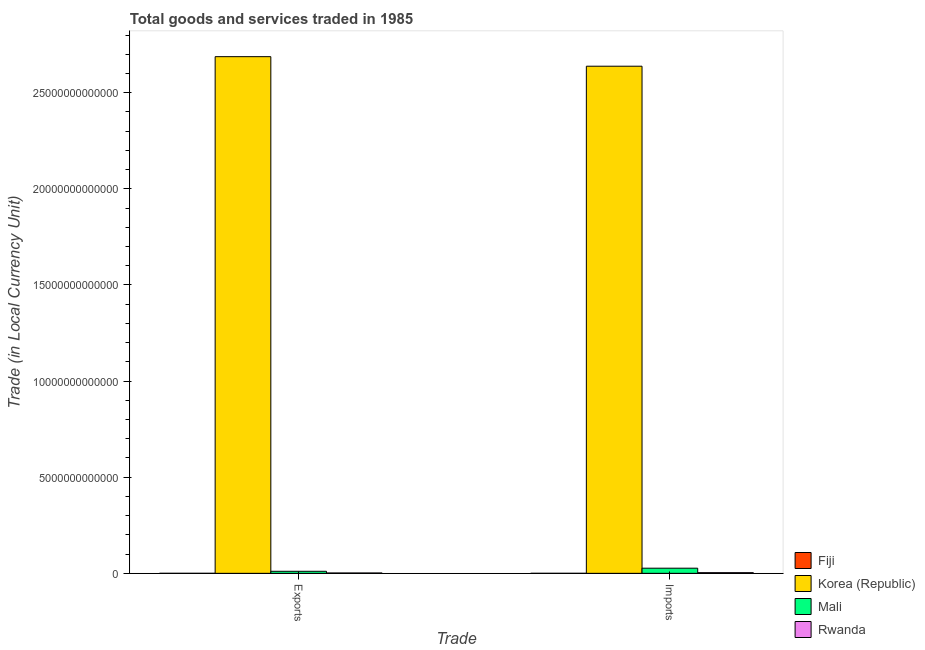How many different coloured bars are there?
Give a very brief answer. 4. How many groups of bars are there?
Your answer should be very brief. 2. How many bars are there on the 2nd tick from the left?
Give a very brief answer. 4. How many bars are there on the 1st tick from the right?
Your answer should be very brief. 4. What is the label of the 1st group of bars from the left?
Provide a short and direct response. Exports. What is the imports of goods and services in Fiji?
Provide a succinct answer. 5.89e+08. Across all countries, what is the maximum imports of goods and services?
Give a very brief answer. 2.64e+13. Across all countries, what is the minimum imports of goods and services?
Your response must be concise. 5.89e+08. In which country was the export of goods and services maximum?
Make the answer very short. Korea (Republic). In which country was the export of goods and services minimum?
Your answer should be compact. Fiji. What is the total export of goods and services in the graph?
Provide a short and direct response. 2.70e+13. What is the difference between the export of goods and services in Fiji and that in Korea (Republic)?
Provide a short and direct response. -2.69e+13. What is the difference between the imports of goods and services in Rwanda and the export of goods and services in Mali?
Provide a short and direct response. -7.19e+1. What is the average export of goods and services per country?
Make the answer very short. 6.75e+12. What is the difference between the export of goods and services and imports of goods and services in Fiji?
Provide a succinct answer. -5.00e+06. What is the ratio of the imports of goods and services in Fiji to that in Rwanda?
Keep it short and to the point. 0.02. Is the export of goods and services in Rwanda less than that in Mali?
Your answer should be compact. Yes. In how many countries, is the export of goods and services greater than the average export of goods and services taken over all countries?
Provide a short and direct response. 1. What does the 1st bar from the right in Exports represents?
Your answer should be very brief. Rwanda. Are all the bars in the graph horizontal?
Your response must be concise. No. What is the difference between two consecutive major ticks on the Y-axis?
Offer a terse response. 5.00e+12. Does the graph contain any zero values?
Your answer should be compact. No. Where does the legend appear in the graph?
Your response must be concise. Bottom right. What is the title of the graph?
Give a very brief answer. Total goods and services traded in 1985. Does "Ghana" appear as one of the legend labels in the graph?
Give a very brief answer. No. What is the label or title of the X-axis?
Give a very brief answer. Trade. What is the label or title of the Y-axis?
Offer a very short reply. Trade (in Local Currency Unit). What is the Trade (in Local Currency Unit) of Fiji in Exports?
Your answer should be compact. 5.84e+08. What is the Trade (in Local Currency Unit) of Korea (Republic) in Exports?
Your answer should be compact. 2.69e+13. What is the Trade (in Local Currency Unit) in Mali in Exports?
Ensure brevity in your answer.  1.06e+11. What is the Trade (in Local Currency Unit) in Rwanda in Exports?
Ensure brevity in your answer.  1.87e+1. What is the Trade (in Local Currency Unit) of Fiji in Imports?
Your answer should be compact. 5.89e+08. What is the Trade (in Local Currency Unit) of Korea (Republic) in Imports?
Provide a succinct answer. 2.64e+13. What is the Trade (in Local Currency Unit) of Mali in Imports?
Give a very brief answer. 2.67e+11. What is the Trade (in Local Currency Unit) of Rwanda in Imports?
Ensure brevity in your answer.  3.45e+1. Across all Trade, what is the maximum Trade (in Local Currency Unit) of Fiji?
Your response must be concise. 5.89e+08. Across all Trade, what is the maximum Trade (in Local Currency Unit) in Korea (Republic)?
Keep it short and to the point. 2.69e+13. Across all Trade, what is the maximum Trade (in Local Currency Unit) in Mali?
Provide a succinct answer. 2.67e+11. Across all Trade, what is the maximum Trade (in Local Currency Unit) of Rwanda?
Offer a very short reply. 3.45e+1. Across all Trade, what is the minimum Trade (in Local Currency Unit) of Fiji?
Give a very brief answer. 5.84e+08. Across all Trade, what is the minimum Trade (in Local Currency Unit) of Korea (Republic)?
Provide a short and direct response. 2.64e+13. Across all Trade, what is the minimum Trade (in Local Currency Unit) of Mali?
Offer a terse response. 1.06e+11. Across all Trade, what is the minimum Trade (in Local Currency Unit) of Rwanda?
Offer a terse response. 1.87e+1. What is the total Trade (in Local Currency Unit) of Fiji in the graph?
Your answer should be very brief. 1.17e+09. What is the total Trade (in Local Currency Unit) in Korea (Republic) in the graph?
Provide a succinct answer. 5.33e+13. What is the total Trade (in Local Currency Unit) of Mali in the graph?
Your answer should be compact. 3.74e+11. What is the total Trade (in Local Currency Unit) of Rwanda in the graph?
Your answer should be compact. 5.33e+1. What is the difference between the Trade (in Local Currency Unit) of Fiji in Exports and that in Imports?
Provide a short and direct response. -5.00e+06. What is the difference between the Trade (in Local Currency Unit) of Korea (Republic) in Exports and that in Imports?
Provide a succinct answer. 4.97e+11. What is the difference between the Trade (in Local Currency Unit) in Mali in Exports and that in Imports?
Provide a short and direct response. -1.61e+11. What is the difference between the Trade (in Local Currency Unit) in Rwanda in Exports and that in Imports?
Your answer should be very brief. -1.58e+1. What is the difference between the Trade (in Local Currency Unit) in Fiji in Exports and the Trade (in Local Currency Unit) in Korea (Republic) in Imports?
Ensure brevity in your answer.  -2.64e+13. What is the difference between the Trade (in Local Currency Unit) of Fiji in Exports and the Trade (in Local Currency Unit) of Mali in Imports?
Provide a short and direct response. -2.67e+11. What is the difference between the Trade (in Local Currency Unit) in Fiji in Exports and the Trade (in Local Currency Unit) in Rwanda in Imports?
Your answer should be very brief. -3.40e+1. What is the difference between the Trade (in Local Currency Unit) of Korea (Republic) in Exports and the Trade (in Local Currency Unit) of Mali in Imports?
Provide a succinct answer. 2.66e+13. What is the difference between the Trade (in Local Currency Unit) in Korea (Republic) in Exports and the Trade (in Local Currency Unit) in Rwanda in Imports?
Offer a terse response. 2.68e+13. What is the difference between the Trade (in Local Currency Unit) in Mali in Exports and the Trade (in Local Currency Unit) in Rwanda in Imports?
Keep it short and to the point. 7.19e+1. What is the average Trade (in Local Currency Unit) of Fiji per Trade?
Keep it short and to the point. 5.86e+08. What is the average Trade (in Local Currency Unit) in Korea (Republic) per Trade?
Provide a succinct answer. 2.66e+13. What is the average Trade (in Local Currency Unit) of Mali per Trade?
Your response must be concise. 1.87e+11. What is the average Trade (in Local Currency Unit) in Rwanda per Trade?
Keep it short and to the point. 2.66e+1. What is the difference between the Trade (in Local Currency Unit) in Fiji and Trade (in Local Currency Unit) in Korea (Republic) in Exports?
Offer a very short reply. -2.69e+13. What is the difference between the Trade (in Local Currency Unit) in Fiji and Trade (in Local Currency Unit) in Mali in Exports?
Give a very brief answer. -1.06e+11. What is the difference between the Trade (in Local Currency Unit) in Fiji and Trade (in Local Currency Unit) in Rwanda in Exports?
Ensure brevity in your answer.  -1.81e+1. What is the difference between the Trade (in Local Currency Unit) in Korea (Republic) and Trade (in Local Currency Unit) in Mali in Exports?
Provide a succinct answer. 2.68e+13. What is the difference between the Trade (in Local Currency Unit) in Korea (Republic) and Trade (in Local Currency Unit) in Rwanda in Exports?
Provide a short and direct response. 2.69e+13. What is the difference between the Trade (in Local Currency Unit) in Mali and Trade (in Local Currency Unit) in Rwanda in Exports?
Offer a terse response. 8.77e+1. What is the difference between the Trade (in Local Currency Unit) in Fiji and Trade (in Local Currency Unit) in Korea (Republic) in Imports?
Provide a succinct answer. -2.64e+13. What is the difference between the Trade (in Local Currency Unit) in Fiji and Trade (in Local Currency Unit) in Mali in Imports?
Provide a short and direct response. -2.67e+11. What is the difference between the Trade (in Local Currency Unit) of Fiji and Trade (in Local Currency Unit) of Rwanda in Imports?
Your response must be concise. -3.40e+1. What is the difference between the Trade (in Local Currency Unit) in Korea (Republic) and Trade (in Local Currency Unit) in Mali in Imports?
Provide a short and direct response. 2.61e+13. What is the difference between the Trade (in Local Currency Unit) in Korea (Republic) and Trade (in Local Currency Unit) in Rwanda in Imports?
Make the answer very short. 2.63e+13. What is the difference between the Trade (in Local Currency Unit) in Mali and Trade (in Local Currency Unit) in Rwanda in Imports?
Your answer should be very brief. 2.33e+11. What is the ratio of the Trade (in Local Currency Unit) in Fiji in Exports to that in Imports?
Offer a very short reply. 0.99. What is the ratio of the Trade (in Local Currency Unit) in Korea (Republic) in Exports to that in Imports?
Offer a very short reply. 1.02. What is the ratio of the Trade (in Local Currency Unit) in Mali in Exports to that in Imports?
Offer a terse response. 0.4. What is the ratio of the Trade (in Local Currency Unit) in Rwanda in Exports to that in Imports?
Provide a short and direct response. 0.54. What is the difference between the highest and the second highest Trade (in Local Currency Unit) of Fiji?
Provide a succinct answer. 5.00e+06. What is the difference between the highest and the second highest Trade (in Local Currency Unit) of Korea (Republic)?
Provide a succinct answer. 4.97e+11. What is the difference between the highest and the second highest Trade (in Local Currency Unit) of Mali?
Offer a very short reply. 1.61e+11. What is the difference between the highest and the second highest Trade (in Local Currency Unit) of Rwanda?
Your answer should be compact. 1.58e+1. What is the difference between the highest and the lowest Trade (in Local Currency Unit) of Fiji?
Your answer should be very brief. 5.00e+06. What is the difference between the highest and the lowest Trade (in Local Currency Unit) of Korea (Republic)?
Your answer should be very brief. 4.97e+11. What is the difference between the highest and the lowest Trade (in Local Currency Unit) of Mali?
Make the answer very short. 1.61e+11. What is the difference between the highest and the lowest Trade (in Local Currency Unit) in Rwanda?
Ensure brevity in your answer.  1.58e+1. 